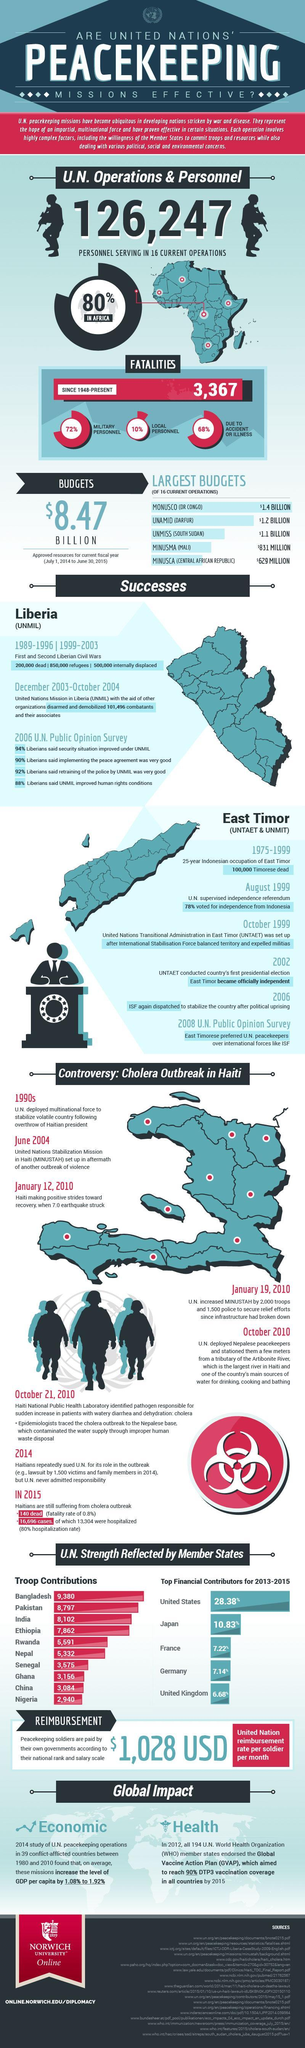Which river is Haiti's main source of water?
Answer the question with a short phrase. Artibonite River Which UN Peace missions helped in independence of East Timor? UNTAET & UNMIT What natural disaster struck Haiti in early 2010? earthquake In which region is the UN operation with second largest budget? Darfur For what purposes was the Artibonite River water used by people of Haiti? drinking, cooking and bathing Which epidemic struck Haiti in October 2010? cholera Which base was found to be the cause for spread of cholera? Nepalese From which country did East Timor get independence from? Indonesia 